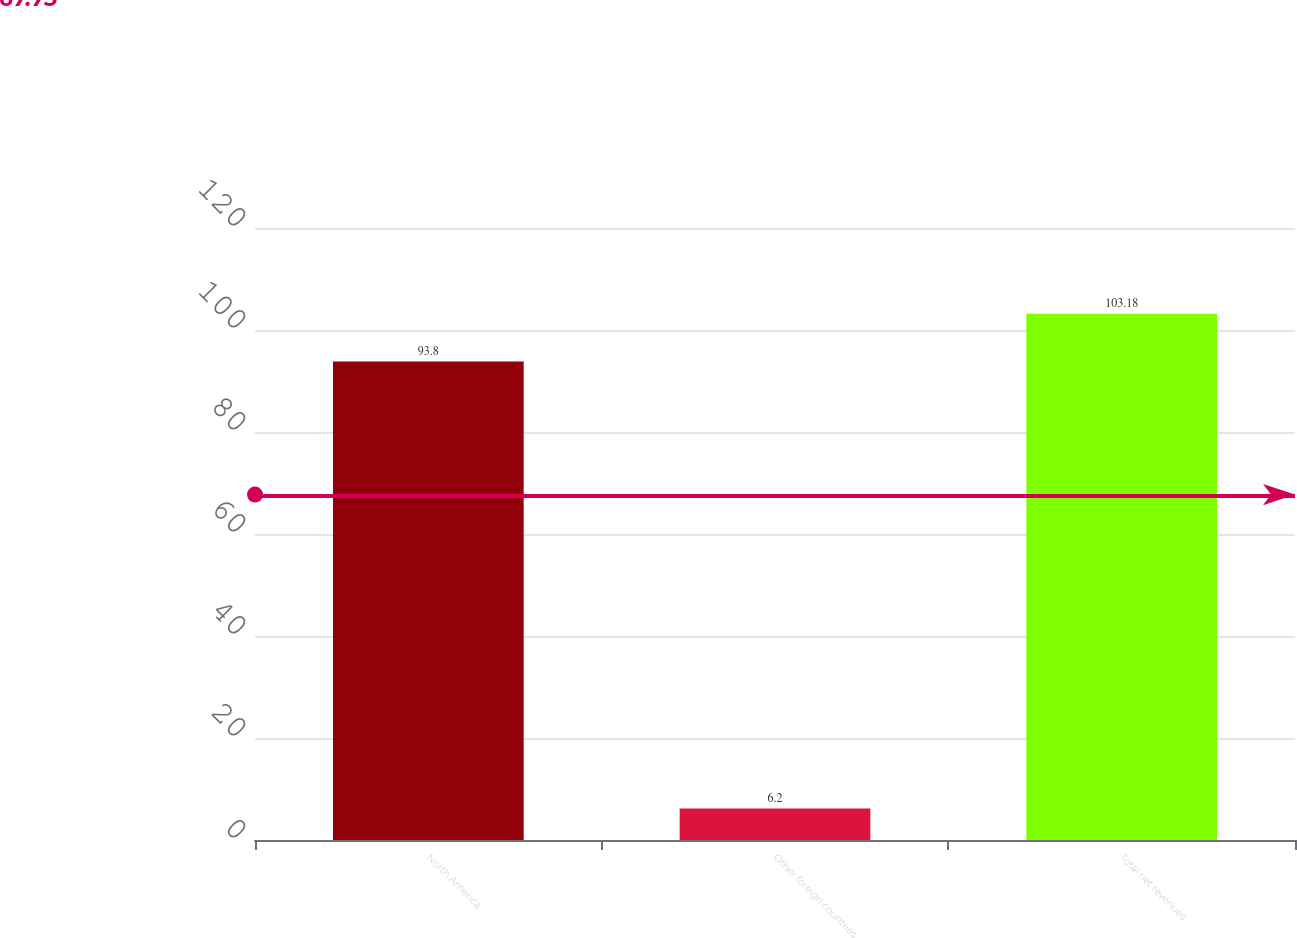Convert chart to OTSL. <chart><loc_0><loc_0><loc_500><loc_500><bar_chart><fcel>North America<fcel>Other foreign countries<fcel>Total net revenues<nl><fcel>93.8<fcel>6.2<fcel>103.18<nl></chart> 